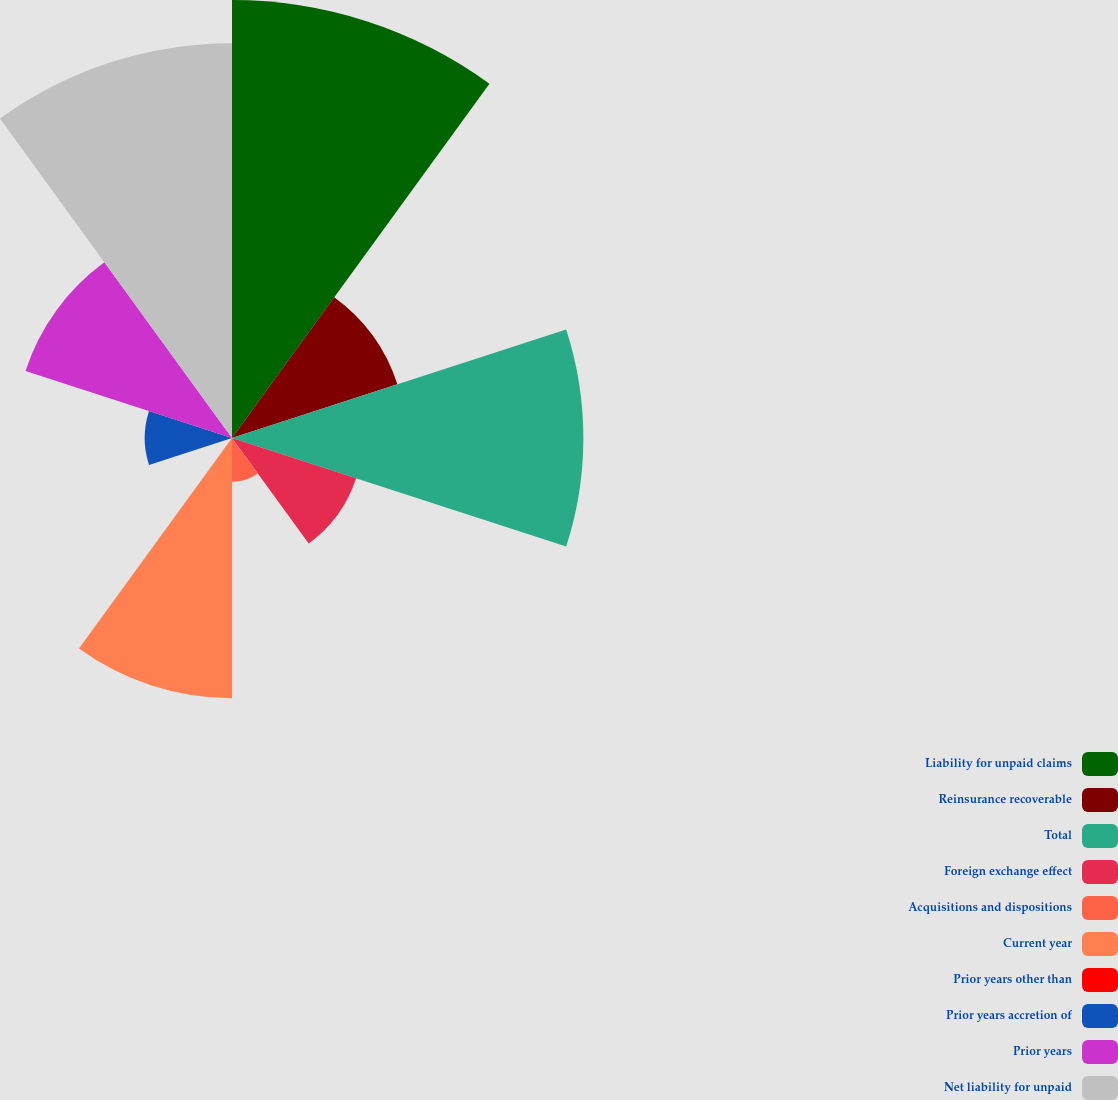<chart> <loc_0><loc_0><loc_500><loc_500><pie_chart><fcel>Liability for unpaid claims<fcel>Reinsurance recoverable<fcel>Total<fcel>Foreign exchange effect<fcel>Acquisitions and dispositions<fcel>Current year<fcel>Prior years other than<fcel>Prior years accretion of<fcel>Prior years<fcel>Net liability for unpaid<nl><fcel>20.88%<fcel>8.29%<fcel>16.75%<fcel>6.22%<fcel>2.09%<fcel>12.41%<fcel>0.03%<fcel>4.16%<fcel>10.35%<fcel>18.82%<nl></chart> 